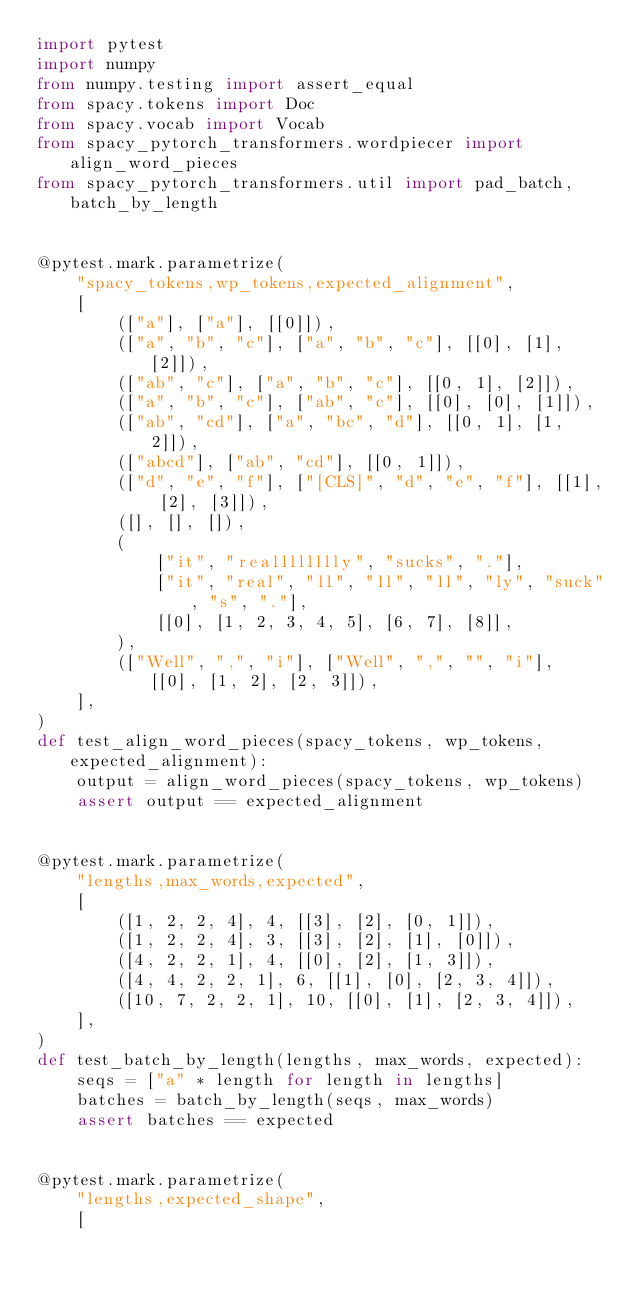<code> <loc_0><loc_0><loc_500><loc_500><_Python_>import pytest
import numpy
from numpy.testing import assert_equal
from spacy.tokens import Doc
from spacy.vocab import Vocab
from spacy_pytorch_transformers.wordpiecer import align_word_pieces
from spacy_pytorch_transformers.util import pad_batch, batch_by_length


@pytest.mark.parametrize(
    "spacy_tokens,wp_tokens,expected_alignment",
    [
        (["a"], ["a"], [[0]]),
        (["a", "b", "c"], ["a", "b", "c"], [[0], [1], [2]]),
        (["ab", "c"], ["a", "b", "c"], [[0, 1], [2]]),
        (["a", "b", "c"], ["ab", "c"], [[0], [0], [1]]),
        (["ab", "cd"], ["a", "bc", "d"], [[0, 1], [1, 2]]),
        (["abcd"], ["ab", "cd"], [[0, 1]]),
        (["d", "e", "f"], ["[CLS]", "d", "e", "f"], [[1], [2], [3]]),
        ([], [], []),
        (
            ["it", "realllllllly", "sucks", "."],
            ["it", "real", "ll", "ll", "ll", "ly", "suck", "s", "."],
            [[0], [1, 2, 3, 4, 5], [6, 7], [8]],
        ),
        (["Well", ",", "i"], ["Well", ",", "", "i"], [[0], [1, 2], [2, 3]]),
    ],
)
def test_align_word_pieces(spacy_tokens, wp_tokens, expected_alignment):
    output = align_word_pieces(spacy_tokens, wp_tokens)
    assert output == expected_alignment


@pytest.mark.parametrize(
    "lengths,max_words,expected",
    [
        ([1, 2, 2, 4], 4, [[3], [2], [0, 1]]),
        ([1, 2, 2, 4], 3, [[3], [2], [1], [0]]),
        ([4, 2, 2, 1], 4, [[0], [2], [1, 3]]),
        ([4, 4, 2, 2, 1], 6, [[1], [0], [2, 3, 4]]),
        ([10, 7, 2, 2, 1], 10, [[0], [1], [2, 3, 4]]),
    ],
)
def test_batch_by_length(lengths, max_words, expected):
    seqs = ["a" * length for length in lengths]
    batches = batch_by_length(seqs, max_words)
    assert batches == expected


@pytest.mark.parametrize(
    "lengths,expected_shape",
    [</code> 